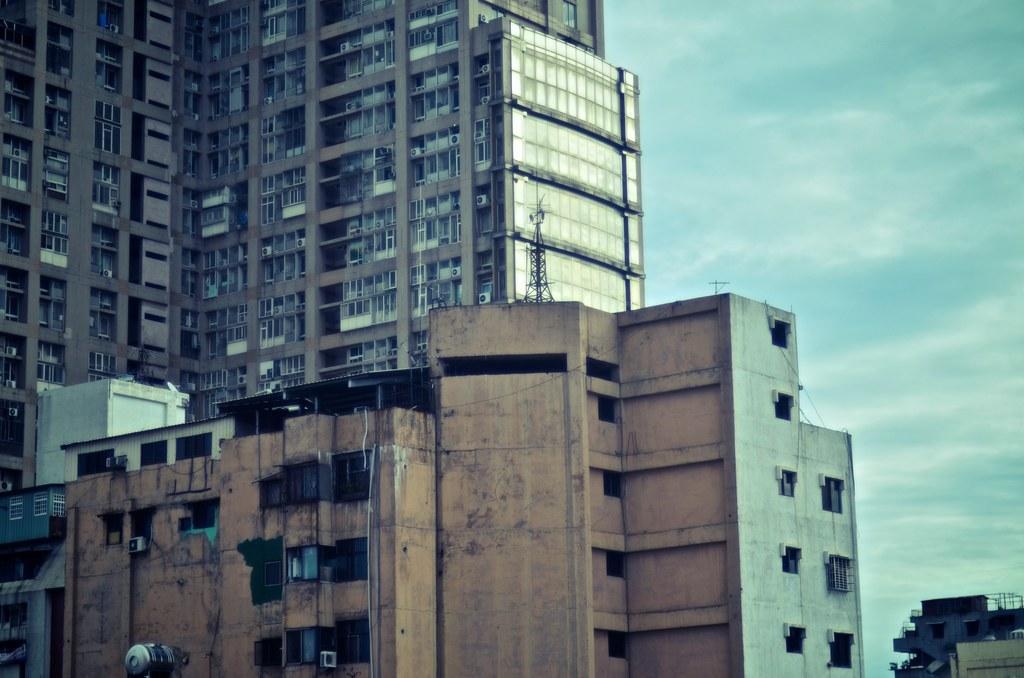How would you summarize this image in a sentence or two? In the center of the image there are buildings. In the background there is sky. 